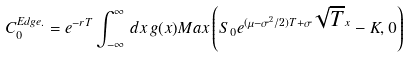Convert formula to latex. <formula><loc_0><loc_0><loc_500><loc_500>C _ { 0 } ^ { E d g e . } = e ^ { - r T } \int _ { - \infty } ^ { \infty } \, d x \, g ( x ) M a x \left ( S _ { 0 } e ^ { ( \mu - \sigma ^ { 2 } / 2 ) T + \sigma \sqrt { T } x } - K , 0 \right )</formula> 